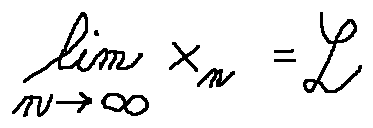<formula> <loc_0><loc_0><loc_500><loc_500>\lim \lim i t s _ { n \rightarrow \infty } x _ { n } = L</formula> 